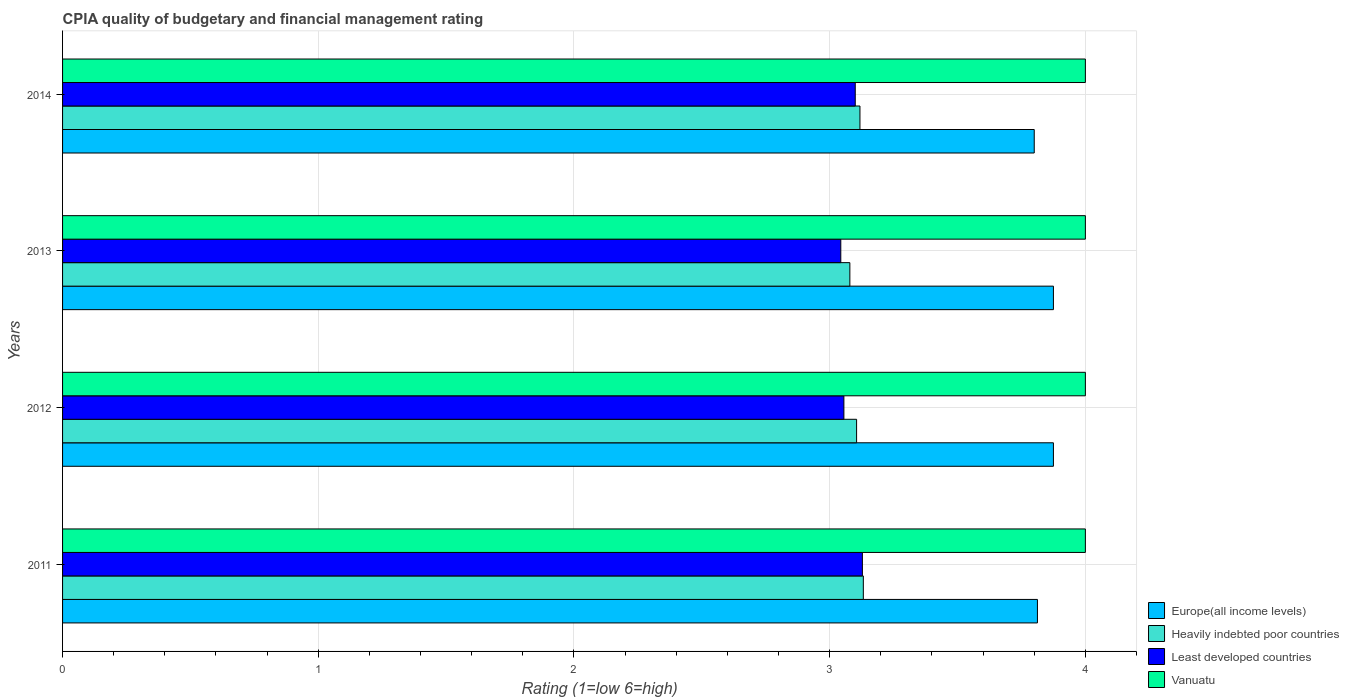How many groups of bars are there?
Your answer should be very brief. 4. Are the number of bars on each tick of the Y-axis equal?
Ensure brevity in your answer.  Yes. How many bars are there on the 2nd tick from the top?
Your answer should be very brief. 4. How many bars are there on the 2nd tick from the bottom?
Your response must be concise. 4. What is the label of the 4th group of bars from the top?
Give a very brief answer. 2011. What is the CPIA rating in Europe(all income levels) in 2013?
Keep it short and to the point. 3.88. Across all years, what is the minimum CPIA rating in Heavily indebted poor countries?
Ensure brevity in your answer.  3.08. In which year was the CPIA rating in Heavily indebted poor countries maximum?
Make the answer very short. 2011. What is the total CPIA rating in Europe(all income levels) in the graph?
Give a very brief answer. 15.36. What is the difference between the CPIA rating in Heavily indebted poor countries in 2012 and that in 2013?
Provide a succinct answer. 0.03. What is the difference between the CPIA rating in Least developed countries in 2014 and the CPIA rating in Europe(all income levels) in 2012?
Offer a very short reply. -0.77. In the year 2013, what is the difference between the CPIA rating in Vanuatu and CPIA rating in Heavily indebted poor countries?
Your answer should be very brief. 0.92. In how many years, is the CPIA rating in Heavily indebted poor countries greater than 3 ?
Make the answer very short. 4. Is the CPIA rating in Vanuatu in 2011 less than that in 2012?
Ensure brevity in your answer.  No. Is the difference between the CPIA rating in Vanuatu in 2013 and 2014 greater than the difference between the CPIA rating in Heavily indebted poor countries in 2013 and 2014?
Provide a short and direct response. Yes. What is the difference between the highest and the second highest CPIA rating in Vanuatu?
Offer a terse response. 0. What is the difference between the highest and the lowest CPIA rating in Europe(all income levels)?
Provide a succinct answer. 0.08. In how many years, is the CPIA rating in Vanuatu greater than the average CPIA rating in Vanuatu taken over all years?
Give a very brief answer. 0. What does the 1st bar from the top in 2011 represents?
Offer a very short reply. Vanuatu. What does the 2nd bar from the bottom in 2014 represents?
Ensure brevity in your answer.  Heavily indebted poor countries. Is it the case that in every year, the sum of the CPIA rating in Vanuatu and CPIA rating in Europe(all income levels) is greater than the CPIA rating in Heavily indebted poor countries?
Keep it short and to the point. Yes. How many bars are there?
Offer a very short reply. 16. How many years are there in the graph?
Make the answer very short. 4. Are the values on the major ticks of X-axis written in scientific E-notation?
Make the answer very short. No. Where does the legend appear in the graph?
Make the answer very short. Bottom right. What is the title of the graph?
Give a very brief answer. CPIA quality of budgetary and financial management rating. What is the label or title of the X-axis?
Your response must be concise. Rating (1=low 6=high). What is the label or title of the Y-axis?
Make the answer very short. Years. What is the Rating (1=low 6=high) in Europe(all income levels) in 2011?
Provide a short and direct response. 3.81. What is the Rating (1=low 6=high) of Heavily indebted poor countries in 2011?
Ensure brevity in your answer.  3.13. What is the Rating (1=low 6=high) in Least developed countries in 2011?
Ensure brevity in your answer.  3.13. What is the Rating (1=low 6=high) in Vanuatu in 2011?
Provide a short and direct response. 4. What is the Rating (1=low 6=high) of Europe(all income levels) in 2012?
Give a very brief answer. 3.88. What is the Rating (1=low 6=high) of Heavily indebted poor countries in 2012?
Offer a very short reply. 3.11. What is the Rating (1=low 6=high) of Least developed countries in 2012?
Provide a succinct answer. 3.06. What is the Rating (1=low 6=high) of Vanuatu in 2012?
Ensure brevity in your answer.  4. What is the Rating (1=low 6=high) of Europe(all income levels) in 2013?
Ensure brevity in your answer.  3.88. What is the Rating (1=low 6=high) in Heavily indebted poor countries in 2013?
Keep it short and to the point. 3.08. What is the Rating (1=low 6=high) of Least developed countries in 2013?
Ensure brevity in your answer.  3.04. What is the Rating (1=low 6=high) in Vanuatu in 2013?
Keep it short and to the point. 4. What is the Rating (1=low 6=high) of Heavily indebted poor countries in 2014?
Provide a succinct answer. 3.12. What is the Rating (1=low 6=high) in Least developed countries in 2014?
Make the answer very short. 3.1. Across all years, what is the maximum Rating (1=low 6=high) in Europe(all income levels)?
Your response must be concise. 3.88. Across all years, what is the maximum Rating (1=low 6=high) in Heavily indebted poor countries?
Your answer should be compact. 3.13. Across all years, what is the maximum Rating (1=low 6=high) of Least developed countries?
Offer a terse response. 3.13. Across all years, what is the maximum Rating (1=low 6=high) in Vanuatu?
Make the answer very short. 4. Across all years, what is the minimum Rating (1=low 6=high) in Heavily indebted poor countries?
Your response must be concise. 3.08. Across all years, what is the minimum Rating (1=low 6=high) of Least developed countries?
Keep it short and to the point. 3.04. What is the total Rating (1=low 6=high) of Europe(all income levels) in the graph?
Your response must be concise. 15.36. What is the total Rating (1=low 6=high) in Heavily indebted poor countries in the graph?
Your answer should be very brief. 12.43. What is the total Rating (1=low 6=high) in Least developed countries in the graph?
Keep it short and to the point. 12.33. What is the total Rating (1=low 6=high) in Vanuatu in the graph?
Keep it short and to the point. 16. What is the difference between the Rating (1=low 6=high) in Europe(all income levels) in 2011 and that in 2012?
Your answer should be very brief. -0.06. What is the difference between the Rating (1=low 6=high) in Heavily indebted poor countries in 2011 and that in 2012?
Provide a succinct answer. 0.03. What is the difference between the Rating (1=low 6=high) of Least developed countries in 2011 and that in 2012?
Give a very brief answer. 0.07. What is the difference between the Rating (1=low 6=high) of Europe(all income levels) in 2011 and that in 2013?
Keep it short and to the point. -0.06. What is the difference between the Rating (1=low 6=high) of Heavily indebted poor countries in 2011 and that in 2013?
Give a very brief answer. 0.05. What is the difference between the Rating (1=low 6=high) in Least developed countries in 2011 and that in 2013?
Make the answer very short. 0.08. What is the difference between the Rating (1=low 6=high) in Europe(all income levels) in 2011 and that in 2014?
Make the answer very short. 0.01. What is the difference between the Rating (1=low 6=high) of Heavily indebted poor countries in 2011 and that in 2014?
Your answer should be compact. 0.01. What is the difference between the Rating (1=low 6=high) of Least developed countries in 2011 and that in 2014?
Your answer should be very brief. 0.03. What is the difference between the Rating (1=low 6=high) in Vanuatu in 2011 and that in 2014?
Keep it short and to the point. 0. What is the difference between the Rating (1=low 6=high) in Europe(all income levels) in 2012 and that in 2013?
Offer a terse response. 0. What is the difference between the Rating (1=low 6=high) in Heavily indebted poor countries in 2012 and that in 2013?
Keep it short and to the point. 0.03. What is the difference between the Rating (1=low 6=high) of Least developed countries in 2012 and that in 2013?
Your answer should be compact. 0.01. What is the difference between the Rating (1=low 6=high) of Europe(all income levels) in 2012 and that in 2014?
Your response must be concise. 0.07. What is the difference between the Rating (1=low 6=high) of Heavily indebted poor countries in 2012 and that in 2014?
Provide a short and direct response. -0.01. What is the difference between the Rating (1=low 6=high) of Least developed countries in 2012 and that in 2014?
Keep it short and to the point. -0.04. What is the difference between the Rating (1=low 6=high) in Vanuatu in 2012 and that in 2014?
Offer a terse response. 0. What is the difference between the Rating (1=low 6=high) in Europe(all income levels) in 2013 and that in 2014?
Provide a short and direct response. 0.07. What is the difference between the Rating (1=low 6=high) of Heavily indebted poor countries in 2013 and that in 2014?
Your answer should be compact. -0.04. What is the difference between the Rating (1=low 6=high) of Least developed countries in 2013 and that in 2014?
Give a very brief answer. -0.06. What is the difference between the Rating (1=low 6=high) in Europe(all income levels) in 2011 and the Rating (1=low 6=high) in Heavily indebted poor countries in 2012?
Ensure brevity in your answer.  0.71. What is the difference between the Rating (1=low 6=high) of Europe(all income levels) in 2011 and the Rating (1=low 6=high) of Least developed countries in 2012?
Provide a succinct answer. 0.76. What is the difference between the Rating (1=low 6=high) in Europe(all income levels) in 2011 and the Rating (1=low 6=high) in Vanuatu in 2012?
Keep it short and to the point. -0.19. What is the difference between the Rating (1=low 6=high) of Heavily indebted poor countries in 2011 and the Rating (1=low 6=high) of Least developed countries in 2012?
Offer a terse response. 0.08. What is the difference between the Rating (1=low 6=high) in Heavily indebted poor countries in 2011 and the Rating (1=low 6=high) in Vanuatu in 2012?
Your response must be concise. -0.87. What is the difference between the Rating (1=low 6=high) of Least developed countries in 2011 and the Rating (1=low 6=high) of Vanuatu in 2012?
Make the answer very short. -0.87. What is the difference between the Rating (1=low 6=high) of Europe(all income levels) in 2011 and the Rating (1=low 6=high) of Heavily indebted poor countries in 2013?
Provide a succinct answer. 0.73. What is the difference between the Rating (1=low 6=high) of Europe(all income levels) in 2011 and the Rating (1=low 6=high) of Least developed countries in 2013?
Offer a very short reply. 0.77. What is the difference between the Rating (1=low 6=high) of Europe(all income levels) in 2011 and the Rating (1=low 6=high) of Vanuatu in 2013?
Your answer should be very brief. -0.19. What is the difference between the Rating (1=low 6=high) in Heavily indebted poor countries in 2011 and the Rating (1=low 6=high) in Least developed countries in 2013?
Provide a short and direct response. 0.09. What is the difference between the Rating (1=low 6=high) of Heavily indebted poor countries in 2011 and the Rating (1=low 6=high) of Vanuatu in 2013?
Offer a terse response. -0.87. What is the difference between the Rating (1=low 6=high) of Least developed countries in 2011 and the Rating (1=low 6=high) of Vanuatu in 2013?
Offer a terse response. -0.87. What is the difference between the Rating (1=low 6=high) of Europe(all income levels) in 2011 and the Rating (1=low 6=high) of Heavily indebted poor countries in 2014?
Your answer should be compact. 0.69. What is the difference between the Rating (1=low 6=high) in Europe(all income levels) in 2011 and the Rating (1=low 6=high) in Least developed countries in 2014?
Offer a very short reply. 0.71. What is the difference between the Rating (1=low 6=high) of Europe(all income levels) in 2011 and the Rating (1=low 6=high) of Vanuatu in 2014?
Your answer should be compact. -0.19. What is the difference between the Rating (1=low 6=high) of Heavily indebted poor countries in 2011 and the Rating (1=low 6=high) of Least developed countries in 2014?
Provide a short and direct response. 0.03. What is the difference between the Rating (1=low 6=high) in Heavily indebted poor countries in 2011 and the Rating (1=low 6=high) in Vanuatu in 2014?
Your answer should be compact. -0.87. What is the difference between the Rating (1=low 6=high) in Least developed countries in 2011 and the Rating (1=low 6=high) in Vanuatu in 2014?
Make the answer very short. -0.87. What is the difference between the Rating (1=low 6=high) of Europe(all income levels) in 2012 and the Rating (1=low 6=high) of Heavily indebted poor countries in 2013?
Offer a terse response. 0.8. What is the difference between the Rating (1=low 6=high) in Europe(all income levels) in 2012 and the Rating (1=low 6=high) in Least developed countries in 2013?
Keep it short and to the point. 0.83. What is the difference between the Rating (1=low 6=high) of Europe(all income levels) in 2012 and the Rating (1=low 6=high) of Vanuatu in 2013?
Your answer should be compact. -0.12. What is the difference between the Rating (1=low 6=high) in Heavily indebted poor countries in 2012 and the Rating (1=low 6=high) in Least developed countries in 2013?
Provide a short and direct response. 0.06. What is the difference between the Rating (1=low 6=high) in Heavily indebted poor countries in 2012 and the Rating (1=low 6=high) in Vanuatu in 2013?
Ensure brevity in your answer.  -0.89. What is the difference between the Rating (1=low 6=high) of Least developed countries in 2012 and the Rating (1=low 6=high) of Vanuatu in 2013?
Your response must be concise. -0.94. What is the difference between the Rating (1=low 6=high) of Europe(all income levels) in 2012 and the Rating (1=low 6=high) of Heavily indebted poor countries in 2014?
Your answer should be compact. 0.76. What is the difference between the Rating (1=low 6=high) in Europe(all income levels) in 2012 and the Rating (1=low 6=high) in Least developed countries in 2014?
Make the answer very short. 0.78. What is the difference between the Rating (1=low 6=high) of Europe(all income levels) in 2012 and the Rating (1=low 6=high) of Vanuatu in 2014?
Provide a succinct answer. -0.12. What is the difference between the Rating (1=low 6=high) of Heavily indebted poor countries in 2012 and the Rating (1=low 6=high) of Least developed countries in 2014?
Offer a terse response. 0.01. What is the difference between the Rating (1=low 6=high) in Heavily indebted poor countries in 2012 and the Rating (1=low 6=high) in Vanuatu in 2014?
Your answer should be very brief. -0.89. What is the difference between the Rating (1=low 6=high) in Least developed countries in 2012 and the Rating (1=low 6=high) in Vanuatu in 2014?
Offer a terse response. -0.94. What is the difference between the Rating (1=low 6=high) of Europe(all income levels) in 2013 and the Rating (1=low 6=high) of Heavily indebted poor countries in 2014?
Offer a terse response. 0.76. What is the difference between the Rating (1=low 6=high) of Europe(all income levels) in 2013 and the Rating (1=low 6=high) of Least developed countries in 2014?
Give a very brief answer. 0.78. What is the difference between the Rating (1=low 6=high) of Europe(all income levels) in 2013 and the Rating (1=low 6=high) of Vanuatu in 2014?
Keep it short and to the point. -0.12. What is the difference between the Rating (1=low 6=high) in Heavily indebted poor countries in 2013 and the Rating (1=low 6=high) in Least developed countries in 2014?
Ensure brevity in your answer.  -0.02. What is the difference between the Rating (1=low 6=high) in Heavily indebted poor countries in 2013 and the Rating (1=low 6=high) in Vanuatu in 2014?
Your answer should be very brief. -0.92. What is the difference between the Rating (1=low 6=high) of Least developed countries in 2013 and the Rating (1=low 6=high) of Vanuatu in 2014?
Provide a succinct answer. -0.96. What is the average Rating (1=low 6=high) of Europe(all income levels) per year?
Your response must be concise. 3.84. What is the average Rating (1=low 6=high) in Heavily indebted poor countries per year?
Ensure brevity in your answer.  3.11. What is the average Rating (1=low 6=high) in Least developed countries per year?
Provide a short and direct response. 3.08. In the year 2011, what is the difference between the Rating (1=low 6=high) in Europe(all income levels) and Rating (1=low 6=high) in Heavily indebted poor countries?
Ensure brevity in your answer.  0.68. In the year 2011, what is the difference between the Rating (1=low 6=high) of Europe(all income levels) and Rating (1=low 6=high) of Least developed countries?
Your answer should be very brief. 0.68. In the year 2011, what is the difference between the Rating (1=low 6=high) in Europe(all income levels) and Rating (1=low 6=high) in Vanuatu?
Offer a very short reply. -0.19. In the year 2011, what is the difference between the Rating (1=low 6=high) in Heavily indebted poor countries and Rating (1=low 6=high) in Least developed countries?
Your response must be concise. 0. In the year 2011, what is the difference between the Rating (1=low 6=high) in Heavily indebted poor countries and Rating (1=low 6=high) in Vanuatu?
Your response must be concise. -0.87. In the year 2011, what is the difference between the Rating (1=low 6=high) in Least developed countries and Rating (1=low 6=high) in Vanuatu?
Your response must be concise. -0.87. In the year 2012, what is the difference between the Rating (1=low 6=high) of Europe(all income levels) and Rating (1=low 6=high) of Heavily indebted poor countries?
Your response must be concise. 0.77. In the year 2012, what is the difference between the Rating (1=low 6=high) in Europe(all income levels) and Rating (1=low 6=high) in Least developed countries?
Offer a very short reply. 0.82. In the year 2012, what is the difference between the Rating (1=low 6=high) of Europe(all income levels) and Rating (1=low 6=high) of Vanuatu?
Offer a terse response. -0.12. In the year 2012, what is the difference between the Rating (1=low 6=high) of Heavily indebted poor countries and Rating (1=low 6=high) of Least developed countries?
Offer a terse response. 0.05. In the year 2012, what is the difference between the Rating (1=low 6=high) in Heavily indebted poor countries and Rating (1=low 6=high) in Vanuatu?
Give a very brief answer. -0.89. In the year 2012, what is the difference between the Rating (1=low 6=high) of Least developed countries and Rating (1=low 6=high) of Vanuatu?
Your response must be concise. -0.94. In the year 2013, what is the difference between the Rating (1=low 6=high) of Europe(all income levels) and Rating (1=low 6=high) of Heavily indebted poor countries?
Offer a very short reply. 0.8. In the year 2013, what is the difference between the Rating (1=low 6=high) of Europe(all income levels) and Rating (1=low 6=high) of Least developed countries?
Give a very brief answer. 0.83. In the year 2013, what is the difference between the Rating (1=low 6=high) in Europe(all income levels) and Rating (1=low 6=high) in Vanuatu?
Your answer should be compact. -0.12. In the year 2013, what is the difference between the Rating (1=low 6=high) of Heavily indebted poor countries and Rating (1=low 6=high) of Least developed countries?
Offer a very short reply. 0.04. In the year 2013, what is the difference between the Rating (1=low 6=high) in Heavily indebted poor countries and Rating (1=low 6=high) in Vanuatu?
Your answer should be very brief. -0.92. In the year 2013, what is the difference between the Rating (1=low 6=high) of Least developed countries and Rating (1=low 6=high) of Vanuatu?
Your answer should be very brief. -0.96. In the year 2014, what is the difference between the Rating (1=low 6=high) of Europe(all income levels) and Rating (1=low 6=high) of Heavily indebted poor countries?
Offer a terse response. 0.68. In the year 2014, what is the difference between the Rating (1=low 6=high) of Heavily indebted poor countries and Rating (1=low 6=high) of Least developed countries?
Keep it short and to the point. 0.02. In the year 2014, what is the difference between the Rating (1=low 6=high) in Heavily indebted poor countries and Rating (1=low 6=high) in Vanuatu?
Your answer should be compact. -0.88. In the year 2014, what is the difference between the Rating (1=low 6=high) of Least developed countries and Rating (1=low 6=high) of Vanuatu?
Keep it short and to the point. -0.9. What is the ratio of the Rating (1=low 6=high) of Europe(all income levels) in 2011 to that in 2012?
Give a very brief answer. 0.98. What is the ratio of the Rating (1=low 6=high) of Heavily indebted poor countries in 2011 to that in 2012?
Make the answer very short. 1.01. What is the ratio of the Rating (1=low 6=high) in Least developed countries in 2011 to that in 2012?
Your answer should be compact. 1.02. What is the ratio of the Rating (1=low 6=high) of Vanuatu in 2011 to that in 2012?
Ensure brevity in your answer.  1. What is the ratio of the Rating (1=low 6=high) of Europe(all income levels) in 2011 to that in 2013?
Your answer should be very brief. 0.98. What is the ratio of the Rating (1=low 6=high) of Heavily indebted poor countries in 2011 to that in 2013?
Your answer should be very brief. 1.02. What is the ratio of the Rating (1=low 6=high) of Least developed countries in 2011 to that in 2013?
Keep it short and to the point. 1.03. What is the ratio of the Rating (1=low 6=high) of Heavily indebted poor countries in 2011 to that in 2014?
Provide a short and direct response. 1. What is the ratio of the Rating (1=low 6=high) of Least developed countries in 2011 to that in 2014?
Give a very brief answer. 1.01. What is the ratio of the Rating (1=low 6=high) in Europe(all income levels) in 2012 to that in 2013?
Your answer should be compact. 1. What is the ratio of the Rating (1=low 6=high) in Heavily indebted poor countries in 2012 to that in 2013?
Offer a terse response. 1.01. What is the ratio of the Rating (1=low 6=high) of Least developed countries in 2012 to that in 2013?
Your answer should be compact. 1. What is the ratio of the Rating (1=low 6=high) in Europe(all income levels) in 2012 to that in 2014?
Keep it short and to the point. 1.02. What is the ratio of the Rating (1=low 6=high) of Heavily indebted poor countries in 2012 to that in 2014?
Make the answer very short. 1. What is the ratio of the Rating (1=low 6=high) of Least developed countries in 2012 to that in 2014?
Your answer should be very brief. 0.99. What is the ratio of the Rating (1=low 6=high) of Europe(all income levels) in 2013 to that in 2014?
Offer a very short reply. 1.02. What is the ratio of the Rating (1=low 6=high) in Heavily indebted poor countries in 2013 to that in 2014?
Your answer should be compact. 0.99. What is the ratio of the Rating (1=low 6=high) in Least developed countries in 2013 to that in 2014?
Provide a succinct answer. 0.98. What is the ratio of the Rating (1=low 6=high) of Vanuatu in 2013 to that in 2014?
Offer a very short reply. 1. What is the difference between the highest and the second highest Rating (1=low 6=high) in Europe(all income levels)?
Provide a short and direct response. 0. What is the difference between the highest and the second highest Rating (1=low 6=high) in Heavily indebted poor countries?
Ensure brevity in your answer.  0.01. What is the difference between the highest and the second highest Rating (1=low 6=high) of Least developed countries?
Give a very brief answer. 0.03. What is the difference between the highest and the second highest Rating (1=low 6=high) of Vanuatu?
Make the answer very short. 0. What is the difference between the highest and the lowest Rating (1=low 6=high) of Europe(all income levels)?
Give a very brief answer. 0.07. What is the difference between the highest and the lowest Rating (1=low 6=high) of Heavily indebted poor countries?
Your answer should be compact. 0.05. What is the difference between the highest and the lowest Rating (1=low 6=high) in Least developed countries?
Offer a terse response. 0.08. What is the difference between the highest and the lowest Rating (1=low 6=high) in Vanuatu?
Provide a short and direct response. 0. 